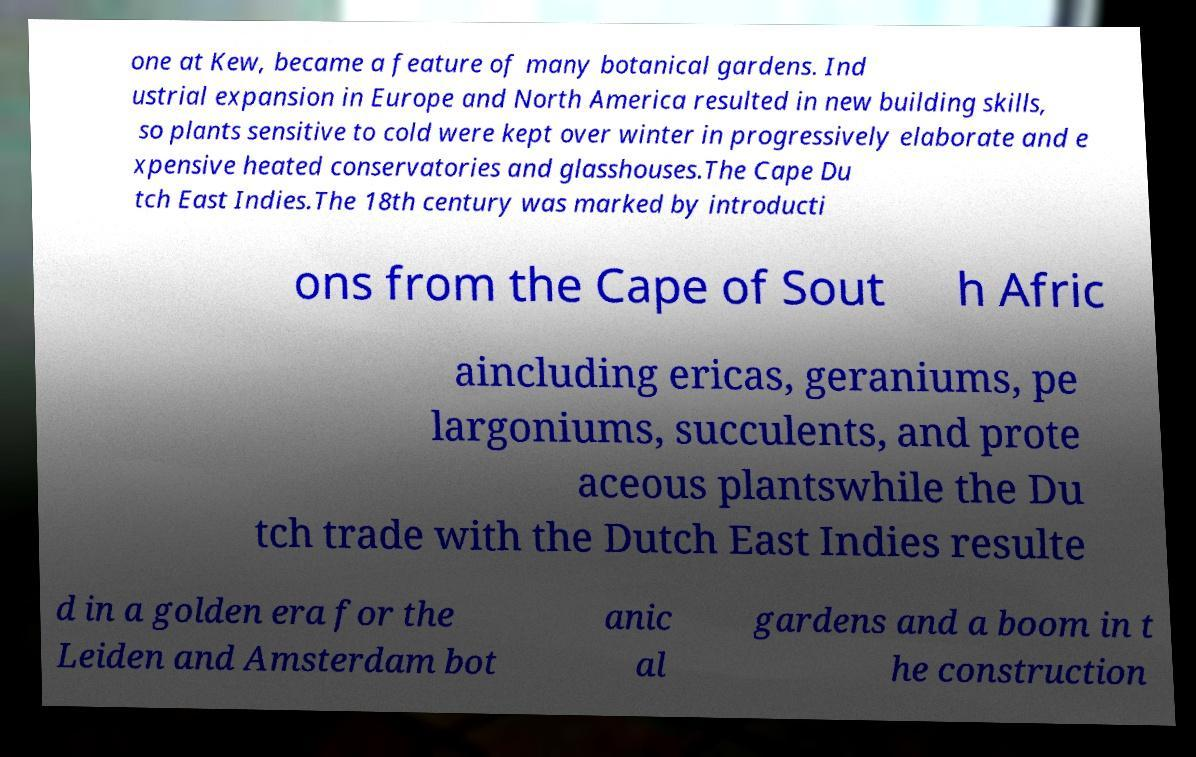Could you assist in decoding the text presented in this image and type it out clearly? one at Kew, became a feature of many botanical gardens. Ind ustrial expansion in Europe and North America resulted in new building skills, so plants sensitive to cold were kept over winter in progressively elaborate and e xpensive heated conservatories and glasshouses.The Cape Du tch East Indies.The 18th century was marked by introducti ons from the Cape of Sout h Afric aincluding ericas, geraniums, pe largoniums, succulents, and prote aceous plantswhile the Du tch trade with the Dutch East Indies resulte d in a golden era for the Leiden and Amsterdam bot anic al gardens and a boom in t he construction 